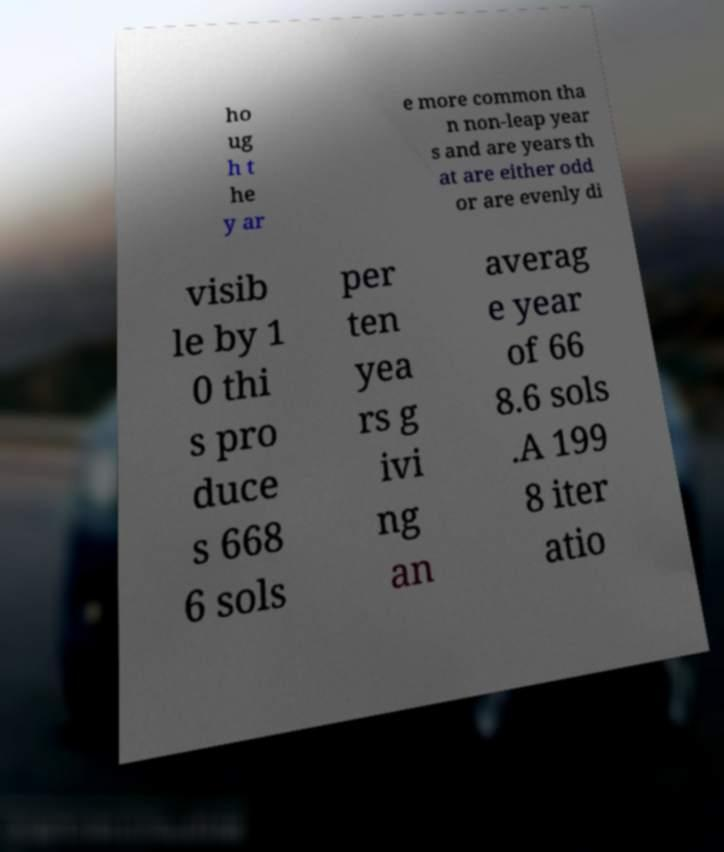There's text embedded in this image that I need extracted. Can you transcribe it verbatim? ho ug h t he y ar e more common tha n non-leap year s and are years th at are either odd or are evenly di visib le by 1 0 thi s pro duce s 668 6 sols per ten yea rs g ivi ng an averag e year of 66 8.6 sols .A 199 8 iter atio 